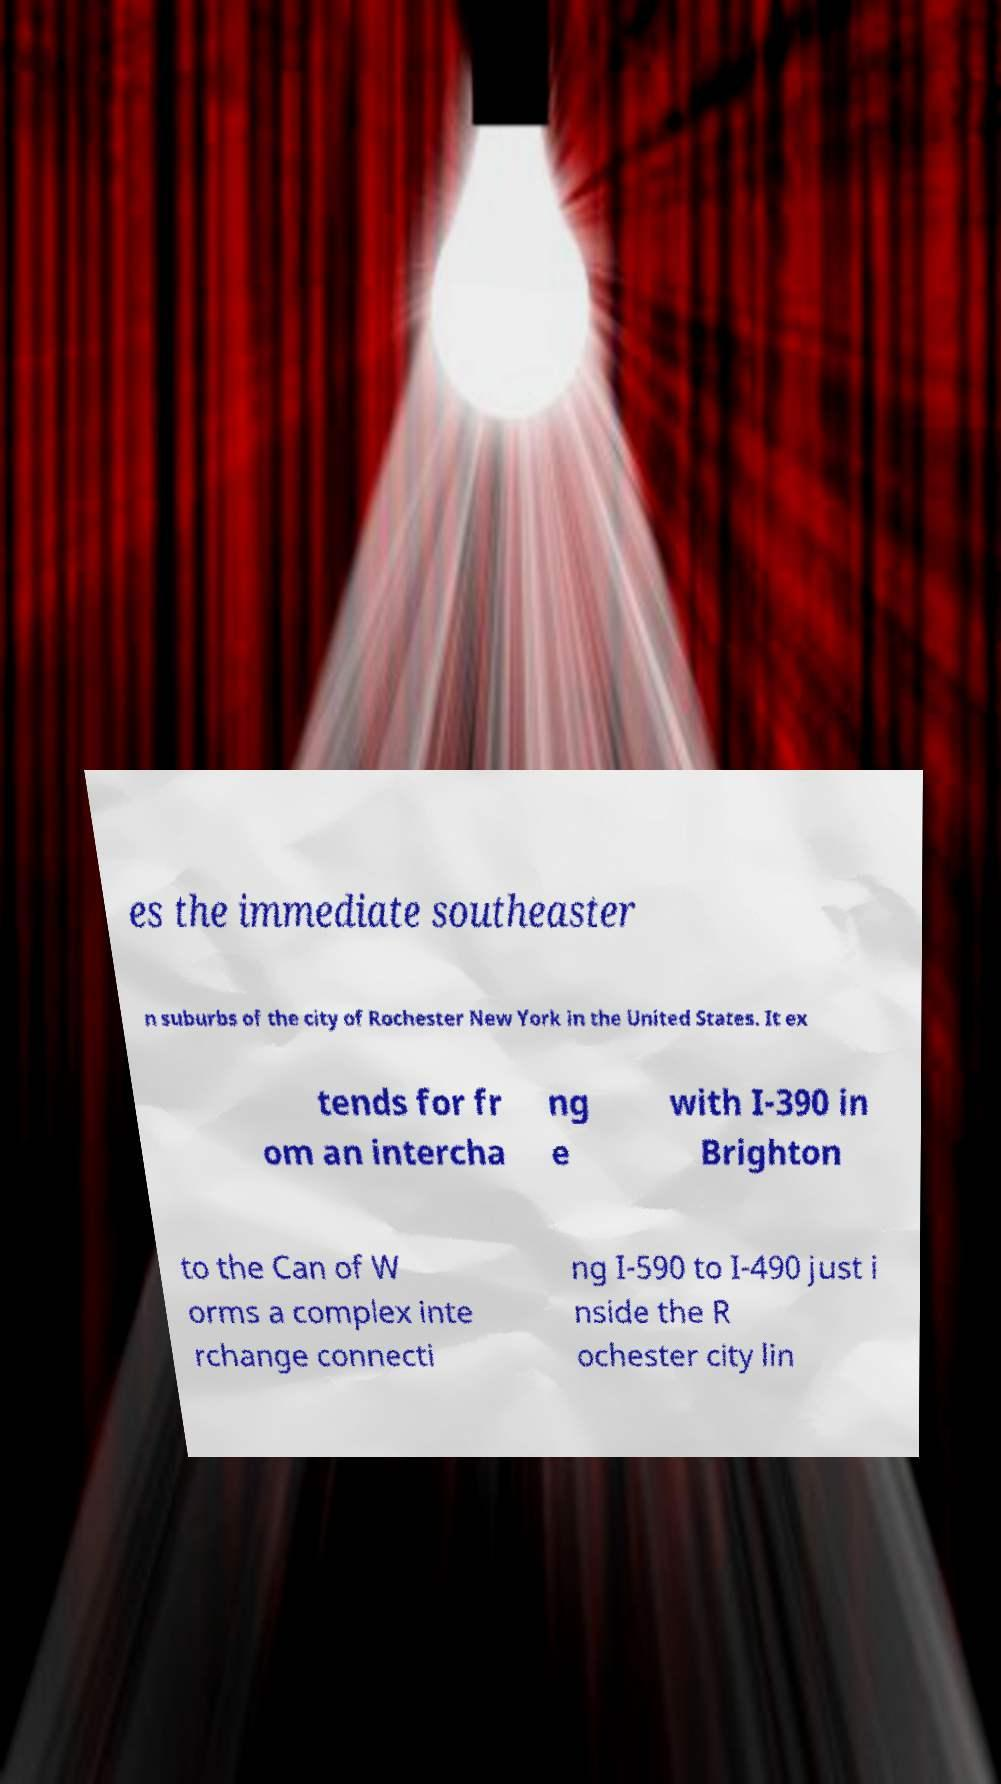There's text embedded in this image that I need extracted. Can you transcribe it verbatim? es the immediate southeaster n suburbs of the city of Rochester New York in the United States. It ex tends for fr om an intercha ng e with I-390 in Brighton to the Can of W orms a complex inte rchange connecti ng I-590 to I-490 just i nside the R ochester city lin 